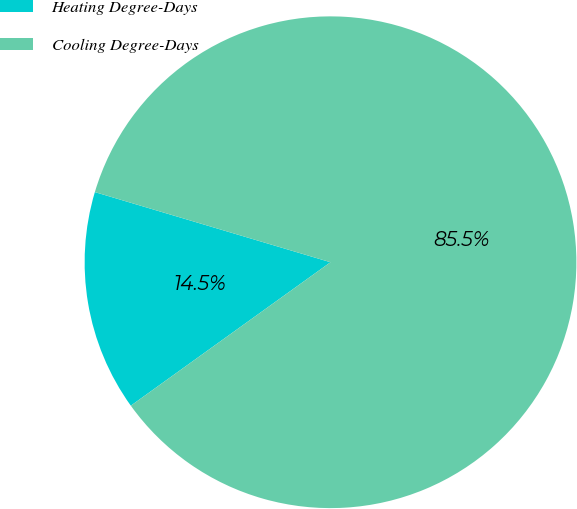Convert chart. <chart><loc_0><loc_0><loc_500><loc_500><pie_chart><fcel>Heating Degree-Days<fcel>Cooling Degree-Days<nl><fcel>14.52%<fcel>85.48%<nl></chart> 